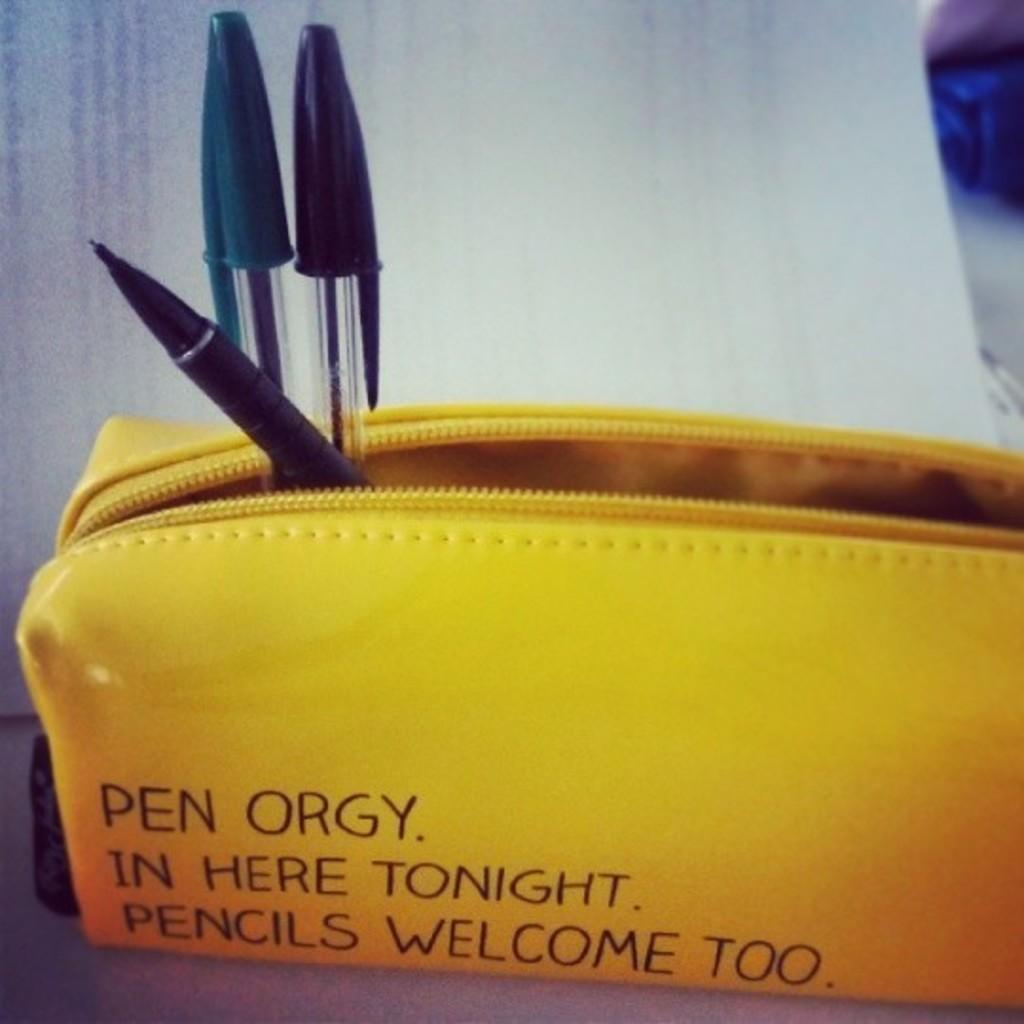What is the color of the pouch in the image? The pouch in the image is yellow. What can be found on the pouch besides its color? There is text written on the pouch. How many pens are inside the pouch? There are three pens inside the pouch. What is the primary piece of furniture in the image? There is a table in the image. Where is the basin located in the image? There is no basin present in the image. What type of frame surrounds the pouch in the image? The pouch in the image does not have a frame surrounding it. 